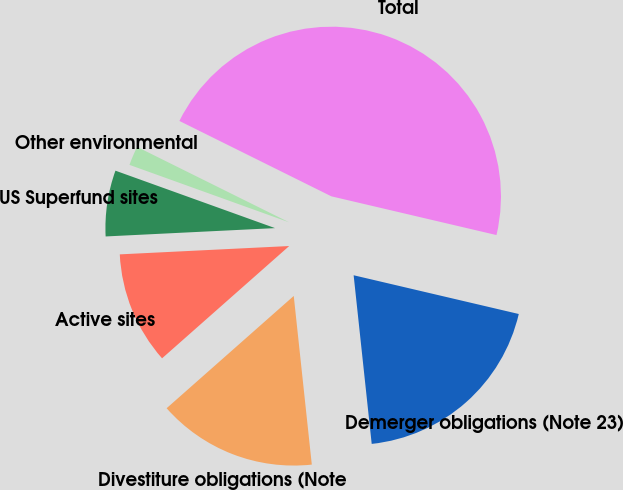Convert chart to OTSL. <chart><loc_0><loc_0><loc_500><loc_500><pie_chart><fcel>Demerger obligations (Note 23)<fcel>Divestiture obligations (Note<fcel>Active sites<fcel>US Superfund sites<fcel>Other environmental<fcel>Total<nl><fcel>19.63%<fcel>15.18%<fcel>10.73%<fcel>6.28%<fcel>1.83%<fcel>46.33%<nl></chart> 